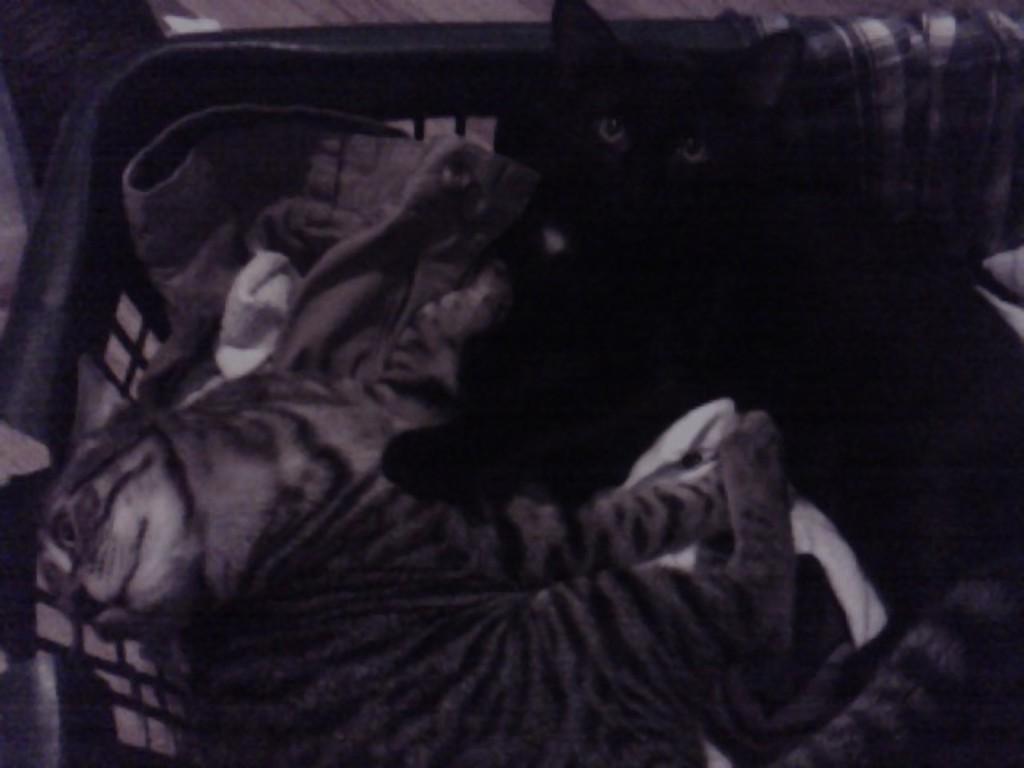Describe this image in one or two sentences. In this image we can see cats which are of black and brown color in the tub in which there are some clothes. 